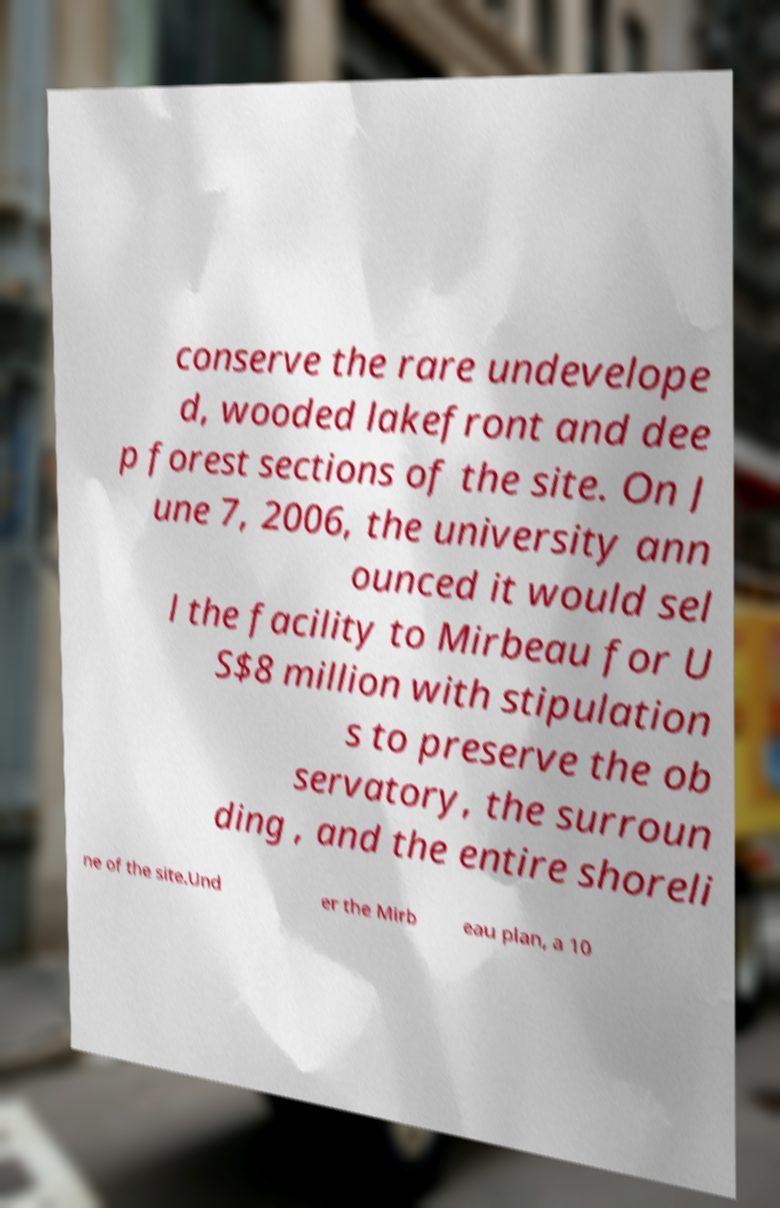For documentation purposes, I need the text within this image transcribed. Could you provide that? conserve the rare undevelope d, wooded lakefront and dee p forest sections of the site. On J une 7, 2006, the university ann ounced it would sel l the facility to Mirbeau for U S$8 million with stipulation s to preserve the ob servatory, the surroun ding , and the entire shoreli ne of the site.Und er the Mirb eau plan, a 10 